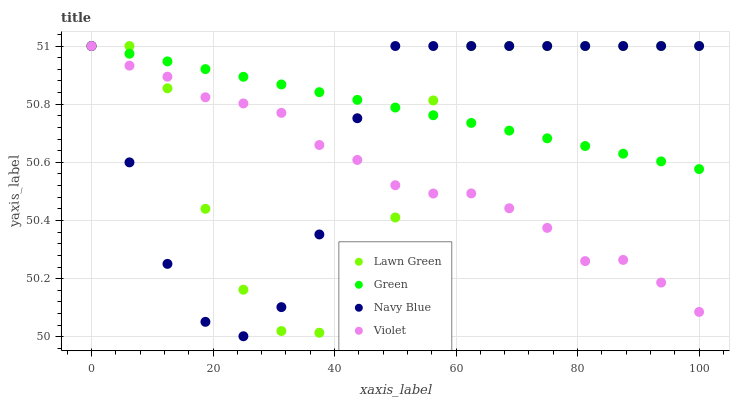Does Violet have the minimum area under the curve?
Answer yes or no. Yes. Does Green have the maximum area under the curve?
Answer yes or no. Yes. Does Green have the minimum area under the curve?
Answer yes or no. No. Does Violet have the maximum area under the curve?
Answer yes or no. No. Is Green the smoothest?
Answer yes or no. Yes. Is Lawn Green the roughest?
Answer yes or no. Yes. Is Violet the smoothest?
Answer yes or no. No. Is Violet the roughest?
Answer yes or no. No. Does Navy Blue have the lowest value?
Answer yes or no. Yes. Does Violet have the lowest value?
Answer yes or no. No. Does Navy Blue have the highest value?
Answer yes or no. Yes. Does Violet intersect Green?
Answer yes or no. Yes. Is Violet less than Green?
Answer yes or no. No. Is Violet greater than Green?
Answer yes or no. No. 